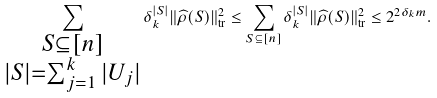Convert formula to latex. <formula><loc_0><loc_0><loc_500><loc_500>\sum _ { \substack { S \subseteq [ n ] \\ | S | = \sum _ { j = 1 } ^ { k } | U _ { j } | } } \delta _ { k } ^ { | S | } \| \widehat { \rho } ( S ) \| _ { \text {tr} } ^ { 2 } \leq \sum _ { S \subseteq [ n ] } \delta _ { k } ^ { | S | } \| \widehat { \rho } ( S ) \| _ { \text {tr} } ^ { 2 } \leq 2 ^ { 2 \delta _ { k } m } .</formula> 